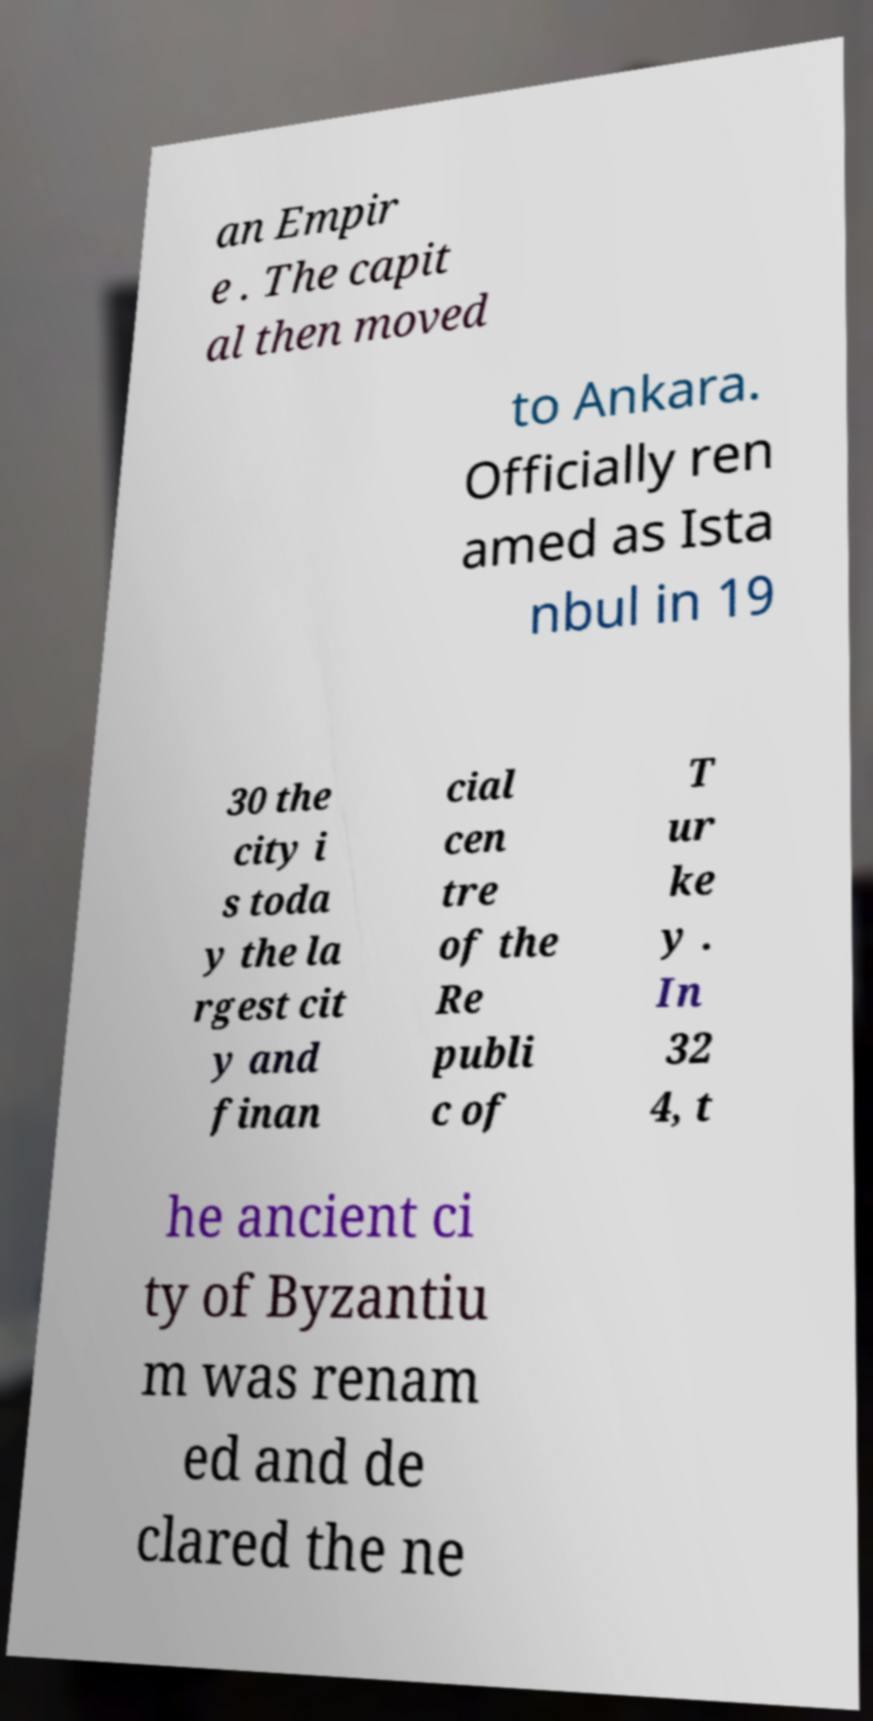Can you read and provide the text displayed in the image?This photo seems to have some interesting text. Can you extract and type it out for me? an Empir e . The capit al then moved to Ankara. Officially ren amed as Ista nbul in 19 30 the city i s toda y the la rgest cit y and finan cial cen tre of the Re publi c of T ur ke y . In 32 4, t he ancient ci ty of Byzantiu m was renam ed and de clared the ne 